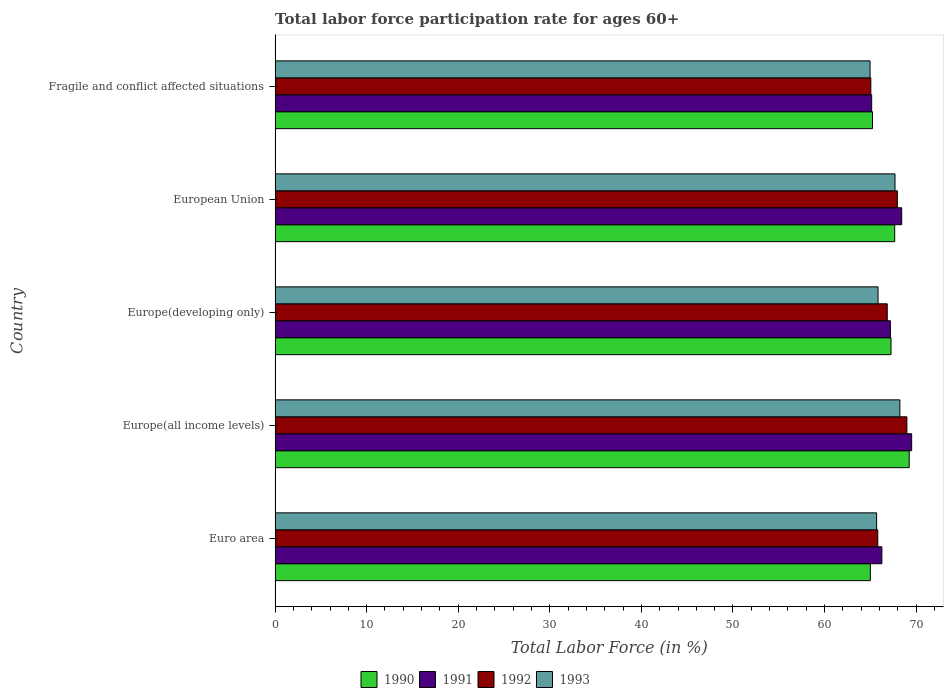Are the number of bars per tick equal to the number of legend labels?
Provide a short and direct response. Yes. What is the label of the 4th group of bars from the top?
Ensure brevity in your answer.  Europe(all income levels). In how many cases, is the number of bars for a given country not equal to the number of legend labels?
Offer a terse response. 0. What is the labor force participation rate in 1990 in Europe(developing only)?
Give a very brief answer. 67.26. Across all countries, what is the maximum labor force participation rate in 1992?
Your response must be concise. 68.99. Across all countries, what is the minimum labor force participation rate in 1992?
Provide a short and direct response. 65.05. In which country was the labor force participation rate in 1990 maximum?
Offer a very short reply. Europe(all income levels). In which country was the labor force participation rate in 1991 minimum?
Keep it short and to the point. Fragile and conflict affected situations. What is the total labor force participation rate in 1993 in the graph?
Give a very brief answer. 332.41. What is the difference between the labor force participation rate in 1990 in Euro area and that in European Union?
Your answer should be very brief. -2.66. What is the difference between the labor force participation rate in 1993 in European Union and the labor force participation rate in 1992 in Europe(all income levels)?
Your answer should be very brief. -1.3. What is the average labor force participation rate in 1993 per country?
Your answer should be very brief. 66.48. What is the difference between the labor force participation rate in 1992 and labor force participation rate in 1993 in Europe(all income levels)?
Offer a terse response. 0.77. In how many countries, is the labor force participation rate in 1990 greater than 20 %?
Ensure brevity in your answer.  5. What is the ratio of the labor force participation rate in 1992 in Europe(developing only) to that in Fragile and conflict affected situations?
Your answer should be very brief. 1.03. Is the labor force participation rate in 1991 in European Union less than that in Fragile and conflict affected situations?
Provide a succinct answer. No. What is the difference between the highest and the second highest labor force participation rate in 1991?
Offer a very short reply. 1.09. What is the difference between the highest and the lowest labor force participation rate in 1991?
Your answer should be very brief. 4.37. Is it the case that in every country, the sum of the labor force participation rate in 1993 and labor force participation rate in 1992 is greater than the sum of labor force participation rate in 1991 and labor force participation rate in 1990?
Offer a very short reply. No. What does the 2nd bar from the bottom in Fragile and conflict affected situations represents?
Provide a succinct answer. 1991. How many bars are there?
Make the answer very short. 20. Does the graph contain any zero values?
Your answer should be very brief. No. Where does the legend appear in the graph?
Your answer should be compact. Bottom center. How many legend labels are there?
Give a very brief answer. 4. What is the title of the graph?
Keep it short and to the point. Total labor force participation rate for ages 60+. Does "1974" appear as one of the legend labels in the graph?
Make the answer very short. No. What is the label or title of the Y-axis?
Your answer should be very brief. Country. What is the Total Labor Force (in %) of 1990 in Euro area?
Make the answer very short. 65. What is the Total Labor Force (in %) in 1991 in Euro area?
Keep it short and to the point. 66.26. What is the Total Labor Force (in %) in 1992 in Euro area?
Your response must be concise. 65.81. What is the Total Labor Force (in %) of 1993 in Euro area?
Your answer should be very brief. 65.69. What is the Total Labor Force (in %) in 1990 in Europe(all income levels)?
Ensure brevity in your answer.  69.24. What is the Total Labor Force (in %) in 1991 in Europe(all income levels)?
Your answer should be very brief. 69.51. What is the Total Labor Force (in %) of 1992 in Europe(all income levels)?
Keep it short and to the point. 68.99. What is the Total Labor Force (in %) of 1993 in Europe(all income levels)?
Your response must be concise. 68.22. What is the Total Labor Force (in %) in 1990 in Europe(developing only)?
Your response must be concise. 67.26. What is the Total Labor Force (in %) in 1991 in Europe(developing only)?
Offer a terse response. 67.19. What is the Total Labor Force (in %) in 1992 in Europe(developing only)?
Your response must be concise. 66.85. What is the Total Labor Force (in %) in 1993 in Europe(developing only)?
Your answer should be very brief. 65.84. What is the Total Labor Force (in %) in 1990 in European Union?
Offer a terse response. 67.66. What is the Total Labor Force (in %) of 1991 in European Union?
Ensure brevity in your answer.  68.42. What is the Total Labor Force (in %) in 1992 in European Union?
Offer a terse response. 67.95. What is the Total Labor Force (in %) of 1993 in European Union?
Offer a very short reply. 67.69. What is the Total Labor Force (in %) in 1990 in Fragile and conflict affected situations?
Your answer should be very brief. 65.24. What is the Total Labor Force (in %) of 1991 in Fragile and conflict affected situations?
Your response must be concise. 65.15. What is the Total Labor Force (in %) of 1992 in Fragile and conflict affected situations?
Give a very brief answer. 65.05. What is the Total Labor Force (in %) in 1993 in Fragile and conflict affected situations?
Your answer should be very brief. 64.97. Across all countries, what is the maximum Total Labor Force (in %) in 1990?
Provide a succinct answer. 69.24. Across all countries, what is the maximum Total Labor Force (in %) in 1991?
Offer a terse response. 69.51. Across all countries, what is the maximum Total Labor Force (in %) in 1992?
Your answer should be compact. 68.99. Across all countries, what is the maximum Total Labor Force (in %) of 1993?
Your response must be concise. 68.22. Across all countries, what is the minimum Total Labor Force (in %) of 1990?
Give a very brief answer. 65. Across all countries, what is the minimum Total Labor Force (in %) of 1991?
Provide a succinct answer. 65.15. Across all countries, what is the minimum Total Labor Force (in %) of 1992?
Your answer should be compact. 65.05. Across all countries, what is the minimum Total Labor Force (in %) of 1993?
Your answer should be very brief. 64.97. What is the total Total Labor Force (in %) in 1990 in the graph?
Keep it short and to the point. 334.4. What is the total Total Labor Force (in %) in 1991 in the graph?
Ensure brevity in your answer.  336.53. What is the total Total Labor Force (in %) of 1992 in the graph?
Your answer should be very brief. 334.65. What is the total Total Labor Force (in %) in 1993 in the graph?
Offer a terse response. 332.41. What is the difference between the Total Labor Force (in %) of 1990 in Euro area and that in Europe(all income levels)?
Provide a succinct answer. -4.24. What is the difference between the Total Labor Force (in %) of 1991 in Euro area and that in Europe(all income levels)?
Your answer should be very brief. -3.25. What is the difference between the Total Labor Force (in %) of 1992 in Euro area and that in Europe(all income levels)?
Your answer should be very brief. -3.18. What is the difference between the Total Labor Force (in %) in 1993 in Euro area and that in Europe(all income levels)?
Provide a short and direct response. -2.54. What is the difference between the Total Labor Force (in %) in 1990 in Euro area and that in Europe(developing only)?
Ensure brevity in your answer.  -2.26. What is the difference between the Total Labor Force (in %) of 1991 in Euro area and that in Europe(developing only)?
Keep it short and to the point. -0.93. What is the difference between the Total Labor Force (in %) in 1992 in Euro area and that in Europe(developing only)?
Keep it short and to the point. -1.03. What is the difference between the Total Labor Force (in %) of 1993 in Euro area and that in Europe(developing only)?
Your response must be concise. -0.16. What is the difference between the Total Labor Force (in %) of 1990 in Euro area and that in European Union?
Make the answer very short. -2.66. What is the difference between the Total Labor Force (in %) in 1991 in Euro area and that in European Union?
Offer a very short reply. -2.16. What is the difference between the Total Labor Force (in %) of 1992 in Euro area and that in European Union?
Offer a terse response. -2.14. What is the difference between the Total Labor Force (in %) in 1993 in Euro area and that in European Union?
Give a very brief answer. -2.01. What is the difference between the Total Labor Force (in %) in 1990 in Euro area and that in Fragile and conflict affected situations?
Your answer should be compact. -0.24. What is the difference between the Total Labor Force (in %) of 1991 in Euro area and that in Fragile and conflict affected situations?
Ensure brevity in your answer.  1.11. What is the difference between the Total Labor Force (in %) in 1992 in Euro area and that in Fragile and conflict affected situations?
Your answer should be very brief. 0.76. What is the difference between the Total Labor Force (in %) in 1993 in Euro area and that in Fragile and conflict affected situations?
Provide a short and direct response. 0.72. What is the difference between the Total Labor Force (in %) in 1990 in Europe(all income levels) and that in Europe(developing only)?
Your response must be concise. 1.99. What is the difference between the Total Labor Force (in %) in 1991 in Europe(all income levels) and that in Europe(developing only)?
Ensure brevity in your answer.  2.33. What is the difference between the Total Labor Force (in %) in 1992 in Europe(all income levels) and that in Europe(developing only)?
Your answer should be compact. 2.15. What is the difference between the Total Labor Force (in %) in 1993 in Europe(all income levels) and that in Europe(developing only)?
Make the answer very short. 2.38. What is the difference between the Total Labor Force (in %) of 1990 in Europe(all income levels) and that in European Union?
Ensure brevity in your answer.  1.58. What is the difference between the Total Labor Force (in %) of 1991 in Europe(all income levels) and that in European Union?
Your answer should be compact. 1.09. What is the difference between the Total Labor Force (in %) in 1992 in Europe(all income levels) and that in European Union?
Provide a short and direct response. 1.04. What is the difference between the Total Labor Force (in %) of 1993 in Europe(all income levels) and that in European Union?
Provide a short and direct response. 0.53. What is the difference between the Total Labor Force (in %) in 1990 in Europe(all income levels) and that in Fragile and conflict affected situations?
Offer a very short reply. 4.01. What is the difference between the Total Labor Force (in %) in 1991 in Europe(all income levels) and that in Fragile and conflict affected situations?
Give a very brief answer. 4.37. What is the difference between the Total Labor Force (in %) of 1992 in Europe(all income levels) and that in Fragile and conflict affected situations?
Provide a short and direct response. 3.94. What is the difference between the Total Labor Force (in %) in 1993 in Europe(all income levels) and that in Fragile and conflict affected situations?
Your answer should be very brief. 3.26. What is the difference between the Total Labor Force (in %) of 1990 in Europe(developing only) and that in European Union?
Keep it short and to the point. -0.4. What is the difference between the Total Labor Force (in %) of 1991 in Europe(developing only) and that in European Union?
Offer a very short reply. -1.24. What is the difference between the Total Labor Force (in %) in 1992 in Europe(developing only) and that in European Union?
Make the answer very short. -1.1. What is the difference between the Total Labor Force (in %) of 1993 in Europe(developing only) and that in European Union?
Offer a very short reply. -1.85. What is the difference between the Total Labor Force (in %) in 1990 in Europe(developing only) and that in Fragile and conflict affected situations?
Give a very brief answer. 2.02. What is the difference between the Total Labor Force (in %) in 1991 in Europe(developing only) and that in Fragile and conflict affected situations?
Your answer should be compact. 2.04. What is the difference between the Total Labor Force (in %) of 1992 in Europe(developing only) and that in Fragile and conflict affected situations?
Your response must be concise. 1.79. What is the difference between the Total Labor Force (in %) in 1993 in Europe(developing only) and that in Fragile and conflict affected situations?
Offer a very short reply. 0.87. What is the difference between the Total Labor Force (in %) of 1990 in European Union and that in Fragile and conflict affected situations?
Keep it short and to the point. 2.42. What is the difference between the Total Labor Force (in %) of 1991 in European Union and that in Fragile and conflict affected situations?
Your answer should be compact. 3.28. What is the difference between the Total Labor Force (in %) of 1992 in European Union and that in Fragile and conflict affected situations?
Ensure brevity in your answer.  2.9. What is the difference between the Total Labor Force (in %) in 1993 in European Union and that in Fragile and conflict affected situations?
Ensure brevity in your answer.  2.72. What is the difference between the Total Labor Force (in %) in 1990 in Euro area and the Total Labor Force (in %) in 1991 in Europe(all income levels)?
Offer a very short reply. -4.51. What is the difference between the Total Labor Force (in %) of 1990 in Euro area and the Total Labor Force (in %) of 1992 in Europe(all income levels)?
Keep it short and to the point. -3.99. What is the difference between the Total Labor Force (in %) in 1990 in Euro area and the Total Labor Force (in %) in 1993 in Europe(all income levels)?
Your answer should be compact. -3.22. What is the difference between the Total Labor Force (in %) of 1991 in Euro area and the Total Labor Force (in %) of 1992 in Europe(all income levels)?
Keep it short and to the point. -2.73. What is the difference between the Total Labor Force (in %) of 1991 in Euro area and the Total Labor Force (in %) of 1993 in Europe(all income levels)?
Provide a succinct answer. -1.97. What is the difference between the Total Labor Force (in %) in 1992 in Euro area and the Total Labor Force (in %) in 1993 in Europe(all income levels)?
Offer a very short reply. -2.41. What is the difference between the Total Labor Force (in %) in 1990 in Euro area and the Total Labor Force (in %) in 1991 in Europe(developing only)?
Give a very brief answer. -2.19. What is the difference between the Total Labor Force (in %) in 1990 in Euro area and the Total Labor Force (in %) in 1992 in Europe(developing only)?
Your answer should be compact. -1.85. What is the difference between the Total Labor Force (in %) in 1990 in Euro area and the Total Labor Force (in %) in 1993 in Europe(developing only)?
Your answer should be compact. -0.84. What is the difference between the Total Labor Force (in %) of 1991 in Euro area and the Total Labor Force (in %) of 1992 in Europe(developing only)?
Make the answer very short. -0.59. What is the difference between the Total Labor Force (in %) in 1991 in Euro area and the Total Labor Force (in %) in 1993 in Europe(developing only)?
Your answer should be compact. 0.42. What is the difference between the Total Labor Force (in %) in 1992 in Euro area and the Total Labor Force (in %) in 1993 in Europe(developing only)?
Ensure brevity in your answer.  -0.03. What is the difference between the Total Labor Force (in %) of 1990 in Euro area and the Total Labor Force (in %) of 1991 in European Union?
Your answer should be compact. -3.42. What is the difference between the Total Labor Force (in %) of 1990 in Euro area and the Total Labor Force (in %) of 1992 in European Union?
Offer a terse response. -2.95. What is the difference between the Total Labor Force (in %) in 1990 in Euro area and the Total Labor Force (in %) in 1993 in European Union?
Provide a short and direct response. -2.69. What is the difference between the Total Labor Force (in %) in 1991 in Euro area and the Total Labor Force (in %) in 1992 in European Union?
Your answer should be very brief. -1.69. What is the difference between the Total Labor Force (in %) in 1991 in Euro area and the Total Labor Force (in %) in 1993 in European Union?
Ensure brevity in your answer.  -1.43. What is the difference between the Total Labor Force (in %) of 1992 in Euro area and the Total Labor Force (in %) of 1993 in European Union?
Your answer should be compact. -1.88. What is the difference between the Total Labor Force (in %) in 1990 in Euro area and the Total Labor Force (in %) in 1991 in Fragile and conflict affected situations?
Offer a very short reply. -0.15. What is the difference between the Total Labor Force (in %) of 1990 in Euro area and the Total Labor Force (in %) of 1992 in Fragile and conflict affected situations?
Keep it short and to the point. -0.05. What is the difference between the Total Labor Force (in %) of 1990 in Euro area and the Total Labor Force (in %) of 1993 in Fragile and conflict affected situations?
Make the answer very short. 0.03. What is the difference between the Total Labor Force (in %) in 1991 in Euro area and the Total Labor Force (in %) in 1992 in Fragile and conflict affected situations?
Give a very brief answer. 1.21. What is the difference between the Total Labor Force (in %) in 1991 in Euro area and the Total Labor Force (in %) in 1993 in Fragile and conflict affected situations?
Your answer should be compact. 1.29. What is the difference between the Total Labor Force (in %) in 1992 in Euro area and the Total Labor Force (in %) in 1993 in Fragile and conflict affected situations?
Your answer should be compact. 0.84. What is the difference between the Total Labor Force (in %) in 1990 in Europe(all income levels) and the Total Labor Force (in %) in 1991 in Europe(developing only)?
Make the answer very short. 2.06. What is the difference between the Total Labor Force (in %) of 1990 in Europe(all income levels) and the Total Labor Force (in %) of 1992 in Europe(developing only)?
Make the answer very short. 2.4. What is the difference between the Total Labor Force (in %) of 1990 in Europe(all income levels) and the Total Labor Force (in %) of 1993 in Europe(developing only)?
Make the answer very short. 3.4. What is the difference between the Total Labor Force (in %) in 1991 in Europe(all income levels) and the Total Labor Force (in %) in 1992 in Europe(developing only)?
Your response must be concise. 2.67. What is the difference between the Total Labor Force (in %) in 1991 in Europe(all income levels) and the Total Labor Force (in %) in 1993 in Europe(developing only)?
Offer a very short reply. 3.67. What is the difference between the Total Labor Force (in %) of 1992 in Europe(all income levels) and the Total Labor Force (in %) of 1993 in Europe(developing only)?
Offer a terse response. 3.15. What is the difference between the Total Labor Force (in %) in 1990 in Europe(all income levels) and the Total Labor Force (in %) in 1991 in European Union?
Keep it short and to the point. 0.82. What is the difference between the Total Labor Force (in %) in 1990 in Europe(all income levels) and the Total Labor Force (in %) in 1992 in European Union?
Ensure brevity in your answer.  1.29. What is the difference between the Total Labor Force (in %) in 1990 in Europe(all income levels) and the Total Labor Force (in %) in 1993 in European Union?
Your answer should be very brief. 1.55. What is the difference between the Total Labor Force (in %) of 1991 in Europe(all income levels) and the Total Labor Force (in %) of 1992 in European Union?
Make the answer very short. 1.56. What is the difference between the Total Labor Force (in %) in 1991 in Europe(all income levels) and the Total Labor Force (in %) in 1993 in European Union?
Provide a succinct answer. 1.82. What is the difference between the Total Labor Force (in %) in 1992 in Europe(all income levels) and the Total Labor Force (in %) in 1993 in European Union?
Keep it short and to the point. 1.3. What is the difference between the Total Labor Force (in %) in 1990 in Europe(all income levels) and the Total Labor Force (in %) in 1991 in Fragile and conflict affected situations?
Your response must be concise. 4.1. What is the difference between the Total Labor Force (in %) in 1990 in Europe(all income levels) and the Total Labor Force (in %) in 1992 in Fragile and conflict affected situations?
Provide a short and direct response. 4.19. What is the difference between the Total Labor Force (in %) in 1990 in Europe(all income levels) and the Total Labor Force (in %) in 1993 in Fragile and conflict affected situations?
Give a very brief answer. 4.28. What is the difference between the Total Labor Force (in %) of 1991 in Europe(all income levels) and the Total Labor Force (in %) of 1992 in Fragile and conflict affected situations?
Your answer should be compact. 4.46. What is the difference between the Total Labor Force (in %) of 1991 in Europe(all income levels) and the Total Labor Force (in %) of 1993 in Fragile and conflict affected situations?
Offer a terse response. 4.54. What is the difference between the Total Labor Force (in %) of 1992 in Europe(all income levels) and the Total Labor Force (in %) of 1993 in Fragile and conflict affected situations?
Your answer should be compact. 4.02. What is the difference between the Total Labor Force (in %) of 1990 in Europe(developing only) and the Total Labor Force (in %) of 1991 in European Union?
Your answer should be compact. -1.16. What is the difference between the Total Labor Force (in %) of 1990 in Europe(developing only) and the Total Labor Force (in %) of 1992 in European Union?
Your answer should be very brief. -0.69. What is the difference between the Total Labor Force (in %) in 1990 in Europe(developing only) and the Total Labor Force (in %) in 1993 in European Union?
Offer a terse response. -0.43. What is the difference between the Total Labor Force (in %) of 1991 in Europe(developing only) and the Total Labor Force (in %) of 1992 in European Union?
Give a very brief answer. -0.76. What is the difference between the Total Labor Force (in %) in 1991 in Europe(developing only) and the Total Labor Force (in %) in 1993 in European Union?
Ensure brevity in your answer.  -0.51. What is the difference between the Total Labor Force (in %) of 1992 in Europe(developing only) and the Total Labor Force (in %) of 1993 in European Union?
Provide a short and direct response. -0.85. What is the difference between the Total Labor Force (in %) of 1990 in Europe(developing only) and the Total Labor Force (in %) of 1991 in Fragile and conflict affected situations?
Offer a very short reply. 2.11. What is the difference between the Total Labor Force (in %) of 1990 in Europe(developing only) and the Total Labor Force (in %) of 1992 in Fragile and conflict affected situations?
Provide a succinct answer. 2.21. What is the difference between the Total Labor Force (in %) of 1990 in Europe(developing only) and the Total Labor Force (in %) of 1993 in Fragile and conflict affected situations?
Make the answer very short. 2.29. What is the difference between the Total Labor Force (in %) of 1991 in Europe(developing only) and the Total Labor Force (in %) of 1992 in Fragile and conflict affected situations?
Offer a terse response. 2.13. What is the difference between the Total Labor Force (in %) of 1991 in Europe(developing only) and the Total Labor Force (in %) of 1993 in Fragile and conflict affected situations?
Offer a terse response. 2.22. What is the difference between the Total Labor Force (in %) in 1992 in Europe(developing only) and the Total Labor Force (in %) in 1993 in Fragile and conflict affected situations?
Offer a terse response. 1.88. What is the difference between the Total Labor Force (in %) of 1990 in European Union and the Total Labor Force (in %) of 1991 in Fragile and conflict affected situations?
Your answer should be compact. 2.51. What is the difference between the Total Labor Force (in %) of 1990 in European Union and the Total Labor Force (in %) of 1992 in Fragile and conflict affected situations?
Your answer should be very brief. 2.61. What is the difference between the Total Labor Force (in %) in 1990 in European Union and the Total Labor Force (in %) in 1993 in Fragile and conflict affected situations?
Offer a very short reply. 2.69. What is the difference between the Total Labor Force (in %) in 1991 in European Union and the Total Labor Force (in %) in 1992 in Fragile and conflict affected situations?
Offer a very short reply. 3.37. What is the difference between the Total Labor Force (in %) in 1991 in European Union and the Total Labor Force (in %) in 1993 in Fragile and conflict affected situations?
Provide a succinct answer. 3.45. What is the difference between the Total Labor Force (in %) of 1992 in European Union and the Total Labor Force (in %) of 1993 in Fragile and conflict affected situations?
Offer a very short reply. 2.98. What is the average Total Labor Force (in %) of 1990 per country?
Your response must be concise. 66.88. What is the average Total Labor Force (in %) in 1991 per country?
Your response must be concise. 67.31. What is the average Total Labor Force (in %) of 1992 per country?
Ensure brevity in your answer.  66.93. What is the average Total Labor Force (in %) in 1993 per country?
Ensure brevity in your answer.  66.48. What is the difference between the Total Labor Force (in %) in 1990 and Total Labor Force (in %) in 1991 in Euro area?
Offer a very short reply. -1.26. What is the difference between the Total Labor Force (in %) of 1990 and Total Labor Force (in %) of 1992 in Euro area?
Offer a terse response. -0.81. What is the difference between the Total Labor Force (in %) in 1990 and Total Labor Force (in %) in 1993 in Euro area?
Your answer should be very brief. -0.69. What is the difference between the Total Labor Force (in %) in 1991 and Total Labor Force (in %) in 1992 in Euro area?
Provide a succinct answer. 0.45. What is the difference between the Total Labor Force (in %) of 1991 and Total Labor Force (in %) of 1993 in Euro area?
Make the answer very short. 0.57. What is the difference between the Total Labor Force (in %) of 1992 and Total Labor Force (in %) of 1993 in Euro area?
Ensure brevity in your answer.  0.13. What is the difference between the Total Labor Force (in %) in 1990 and Total Labor Force (in %) in 1991 in Europe(all income levels)?
Provide a succinct answer. -0.27. What is the difference between the Total Labor Force (in %) of 1990 and Total Labor Force (in %) of 1992 in Europe(all income levels)?
Offer a terse response. 0.25. What is the difference between the Total Labor Force (in %) in 1990 and Total Labor Force (in %) in 1993 in Europe(all income levels)?
Your response must be concise. 1.02. What is the difference between the Total Labor Force (in %) of 1991 and Total Labor Force (in %) of 1992 in Europe(all income levels)?
Ensure brevity in your answer.  0.52. What is the difference between the Total Labor Force (in %) in 1991 and Total Labor Force (in %) in 1993 in Europe(all income levels)?
Provide a short and direct response. 1.29. What is the difference between the Total Labor Force (in %) of 1992 and Total Labor Force (in %) of 1993 in Europe(all income levels)?
Ensure brevity in your answer.  0.77. What is the difference between the Total Labor Force (in %) of 1990 and Total Labor Force (in %) of 1991 in Europe(developing only)?
Provide a short and direct response. 0.07. What is the difference between the Total Labor Force (in %) of 1990 and Total Labor Force (in %) of 1992 in Europe(developing only)?
Give a very brief answer. 0.41. What is the difference between the Total Labor Force (in %) of 1990 and Total Labor Force (in %) of 1993 in Europe(developing only)?
Provide a succinct answer. 1.42. What is the difference between the Total Labor Force (in %) of 1991 and Total Labor Force (in %) of 1992 in Europe(developing only)?
Make the answer very short. 0.34. What is the difference between the Total Labor Force (in %) of 1991 and Total Labor Force (in %) of 1993 in Europe(developing only)?
Offer a terse response. 1.34. What is the difference between the Total Labor Force (in %) in 1992 and Total Labor Force (in %) in 1993 in Europe(developing only)?
Make the answer very short. 1. What is the difference between the Total Labor Force (in %) of 1990 and Total Labor Force (in %) of 1991 in European Union?
Make the answer very short. -0.76. What is the difference between the Total Labor Force (in %) in 1990 and Total Labor Force (in %) in 1992 in European Union?
Ensure brevity in your answer.  -0.29. What is the difference between the Total Labor Force (in %) in 1990 and Total Labor Force (in %) in 1993 in European Union?
Make the answer very short. -0.03. What is the difference between the Total Labor Force (in %) in 1991 and Total Labor Force (in %) in 1992 in European Union?
Give a very brief answer. 0.47. What is the difference between the Total Labor Force (in %) in 1991 and Total Labor Force (in %) in 1993 in European Union?
Offer a very short reply. 0.73. What is the difference between the Total Labor Force (in %) of 1992 and Total Labor Force (in %) of 1993 in European Union?
Your response must be concise. 0.26. What is the difference between the Total Labor Force (in %) in 1990 and Total Labor Force (in %) in 1991 in Fragile and conflict affected situations?
Provide a short and direct response. 0.09. What is the difference between the Total Labor Force (in %) in 1990 and Total Labor Force (in %) in 1992 in Fragile and conflict affected situations?
Offer a terse response. 0.18. What is the difference between the Total Labor Force (in %) in 1990 and Total Labor Force (in %) in 1993 in Fragile and conflict affected situations?
Give a very brief answer. 0.27. What is the difference between the Total Labor Force (in %) in 1991 and Total Labor Force (in %) in 1992 in Fragile and conflict affected situations?
Offer a terse response. 0.09. What is the difference between the Total Labor Force (in %) in 1991 and Total Labor Force (in %) in 1993 in Fragile and conflict affected situations?
Provide a succinct answer. 0.18. What is the difference between the Total Labor Force (in %) of 1992 and Total Labor Force (in %) of 1993 in Fragile and conflict affected situations?
Keep it short and to the point. 0.08. What is the ratio of the Total Labor Force (in %) of 1990 in Euro area to that in Europe(all income levels)?
Provide a succinct answer. 0.94. What is the ratio of the Total Labor Force (in %) of 1991 in Euro area to that in Europe(all income levels)?
Your answer should be very brief. 0.95. What is the ratio of the Total Labor Force (in %) of 1992 in Euro area to that in Europe(all income levels)?
Offer a terse response. 0.95. What is the ratio of the Total Labor Force (in %) of 1993 in Euro area to that in Europe(all income levels)?
Provide a short and direct response. 0.96. What is the ratio of the Total Labor Force (in %) of 1990 in Euro area to that in Europe(developing only)?
Ensure brevity in your answer.  0.97. What is the ratio of the Total Labor Force (in %) of 1991 in Euro area to that in Europe(developing only)?
Ensure brevity in your answer.  0.99. What is the ratio of the Total Labor Force (in %) in 1992 in Euro area to that in Europe(developing only)?
Offer a very short reply. 0.98. What is the ratio of the Total Labor Force (in %) of 1990 in Euro area to that in European Union?
Provide a succinct answer. 0.96. What is the ratio of the Total Labor Force (in %) of 1991 in Euro area to that in European Union?
Give a very brief answer. 0.97. What is the ratio of the Total Labor Force (in %) in 1992 in Euro area to that in European Union?
Keep it short and to the point. 0.97. What is the ratio of the Total Labor Force (in %) in 1993 in Euro area to that in European Union?
Provide a succinct answer. 0.97. What is the ratio of the Total Labor Force (in %) of 1990 in Euro area to that in Fragile and conflict affected situations?
Ensure brevity in your answer.  1. What is the ratio of the Total Labor Force (in %) of 1991 in Euro area to that in Fragile and conflict affected situations?
Offer a terse response. 1.02. What is the ratio of the Total Labor Force (in %) of 1992 in Euro area to that in Fragile and conflict affected situations?
Provide a succinct answer. 1.01. What is the ratio of the Total Labor Force (in %) in 1993 in Euro area to that in Fragile and conflict affected situations?
Your answer should be compact. 1.01. What is the ratio of the Total Labor Force (in %) in 1990 in Europe(all income levels) to that in Europe(developing only)?
Your answer should be compact. 1.03. What is the ratio of the Total Labor Force (in %) of 1991 in Europe(all income levels) to that in Europe(developing only)?
Offer a terse response. 1.03. What is the ratio of the Total Labor Force (in %) of 1992 in Europe(all income levels) to that in Europe(developing only)?
Make the answer very short. 1.03. What is the ratio of the Total Labor Force (in %) of 1993 in Europe(all income levels) to that in Europe(developing only)?
Offer a terse response. 1.04. What is the ratio of the Total Labor Force (in %) of 1990 in Europe(all income levels) to that in European Union?
Your answer should be very brief. 1.02. What is the ratio of the Total Labor Force (in %) in 1991 in Europe(all income levels) to that in European Union?
Keep it short and to the point. 1.02. What is the ratio of the Total Labor Force (in %) in 1992 in Europe(all income levels) to that in European Union?
Offer a very short reply. 1.02. What is the ratio of the Total Labor Force (in %) in 1993 in Europe(all income levels) to that in European Union?
Offer a very short reply. 1.01. What is the ratio of the Total Labor Force (in %) in 1990 in Europe(all income levels) to that in Fragile and conflict affected situations?
Give a very brief answer. 1.06. What is the ratio of the Total Labor Force (in %) of 1991 in Europe(all income levels) to that in Fragile and conflict affected situations?
Keep it short and to the point. 1.07. What is the ratio of the Total Labor Force (in %) of 1992 in Europe(all income levels) to that in Fragile and conflict affected situations?
Your answer should be compact. 1.06. What is the ratio of the Total Labor Force (in %) of 1993 in Europe(all income levels) to that in Fragile and conflict affected situations?
Provide a succinct answer. 1.05. What is the ratio of the Total Labor Force (in %) in 1991 in Europe(developing only) to that in European Union?
Offer a terse response. 0.98. What is the ratio of the Total Labor Force (in %) in 1992 in Europe(developing only) to that in European Union?
Give a very brief answer. 0.98. What is the ratio of the Total Labor Force (in %) of 1993 in Europe(developing only) to that in European Union?
Offer a very short reply. 0.97. What is the ratio of the Total Labor Force (in %) of 1990 in Europe(developing only) to that in Fragile and conflict affected situations?
Your response must be concise. 1.03. What is the ratio of the Total Labor Force (in %) of 1991 in Europe(developing only) to that in Fragile and conflict affected situations?
Your answer should be very brief. 1.03. What is the ratio of the Total Labor Force (in %) in 1992 in Europe(developing only) to that in Fragile and conflict affected situations?
Your answer should be very brief. 1.03. What is the ratio of the Total Labor Force (in %) in 1993 in Europe(developing only) to that in Fragile and conflict affected situations?
Make the answer very short. 1.01. What is the ratio of the Total Labor Force (in %) in 1990 in European Union to that in Fragile and conflict affected situations?
Your answer should be compact. 1.04. What is the ratio of the Total Labor Force (in %) of 1991 in European Union to that in Fragile and conflict affected situations?
Provide a succinct answer. 1.05. What is the ratio of the Total Labor Force (in %) in 1992 in European Union to that in Fragile and conflict affected situations?
Ensure brevity in your answer.  1.04. What is the ratio of the Total Labor Force (in %) in 1993 in European Union to that in Fragile and conflict affected situations?
Ensure brevity in your answer.  1.04. What is the difference between the highest and the second highest Total Labor Force (in %) in 1990?
Provide a short and direct response. 1.58. What is the difference between the highest and the second highest Total Labor Force (in %) of 1991?
Ensure brevity in your answer.  1.09. What is the difference between the highest and the second highest Total Labor Force (in %) in 1992?
Ensure brevity in your answer.  1.04. What is the difference between the highest and the second highest Total Labor Force (in %) in 1993?
Ensure brevity in your answer.  0.53. What is the difference between the highest and the lowest Total Labor Force (in %) of 1990?
Your answer should be very brief. 4.24. What is the difference between the highest and the lowest Total Labor Force (in %) of 1991?
Your answer should be very brief. 4.37. What is the difference between the highest and the lowest Total Labor Force (in %) in 1992?
Offer a terse response. 3.94. What is the difference between the highest and the lowest Total Labor Force (in %) in 1993?
Provide a short and direct response. 3.26. 